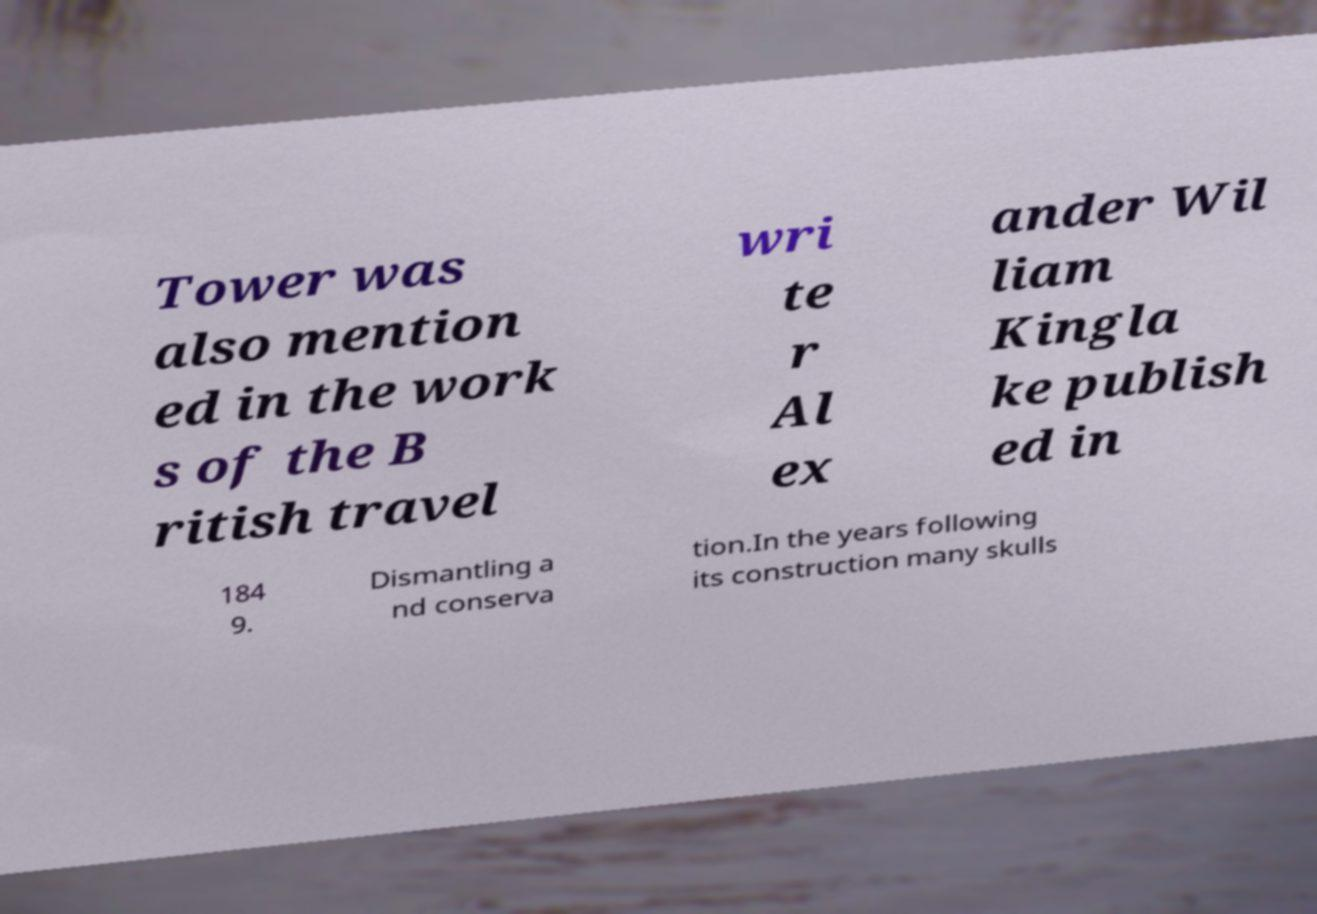Can you accurately transcribe the text from the provided image for me? Tower was also mention ed in the work s of the B ritish travel wri te r Al ex ander Wil liam Kingla ke publish ed in 184 9. Dismantling a nd conserva tion.In the years following its construction many skulls 